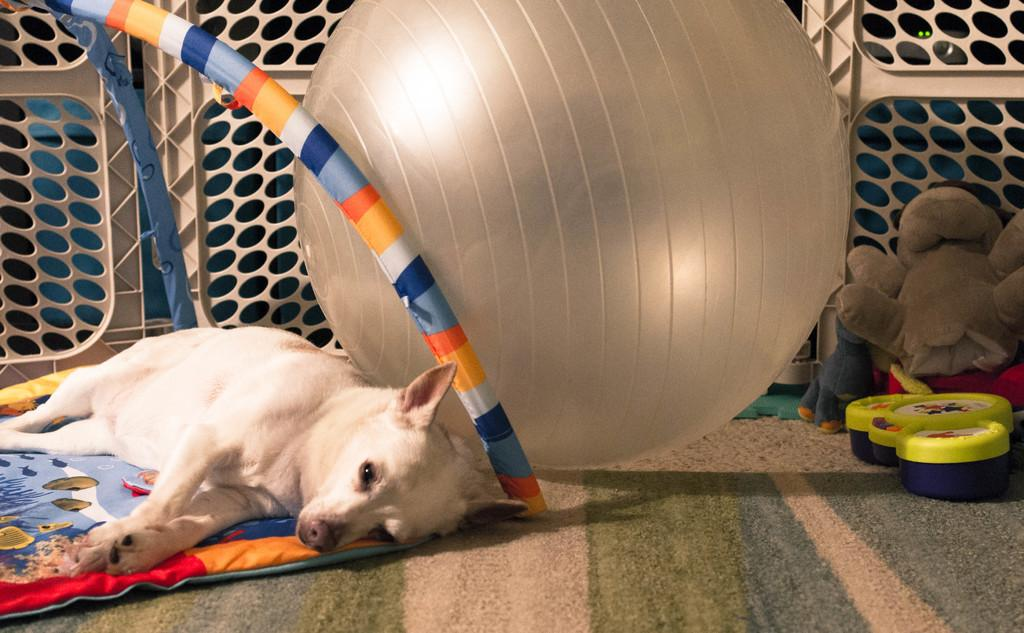What animal is lying on the floor in the image? There is a dog lying on the floor in the image. What type of flooring is visible in the image? There is a carpet in the image. What type of toys are present in the image? There are soft toys in the image. What type of bedding is visible in the image? There is a quilt in the image. What type of machine is visible in the image? There is no machine present in the image. What type of doll is lying next to the dog in the image? There is no doll present in the image; it is a dog lying on the floor. 